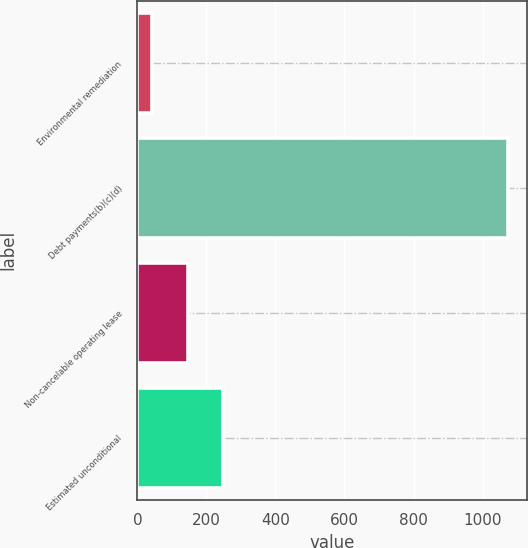Convert chart. <chart><loc_0><loc_0><loc_500><loc_500><bar_chart><fcel>Environmental remediation<fcel>Debt payments(b)(c)(d)<fcel>Non-cancelable operating lease<fcel>Estimated unconditional<nl><fcel>43<fcel>1075<fcel>146.2<fcel>249.4<nl></chart> 